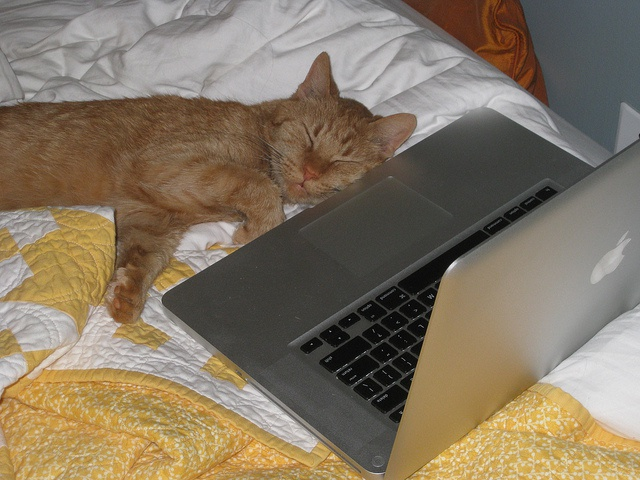Describe the objects in this image and their specific colors. I can see bed in gray, darkgray, tan, and lightgray tones, laptop in gray, black, tan, and darkgray tones, and cat in gray and maroon tones in this image. 